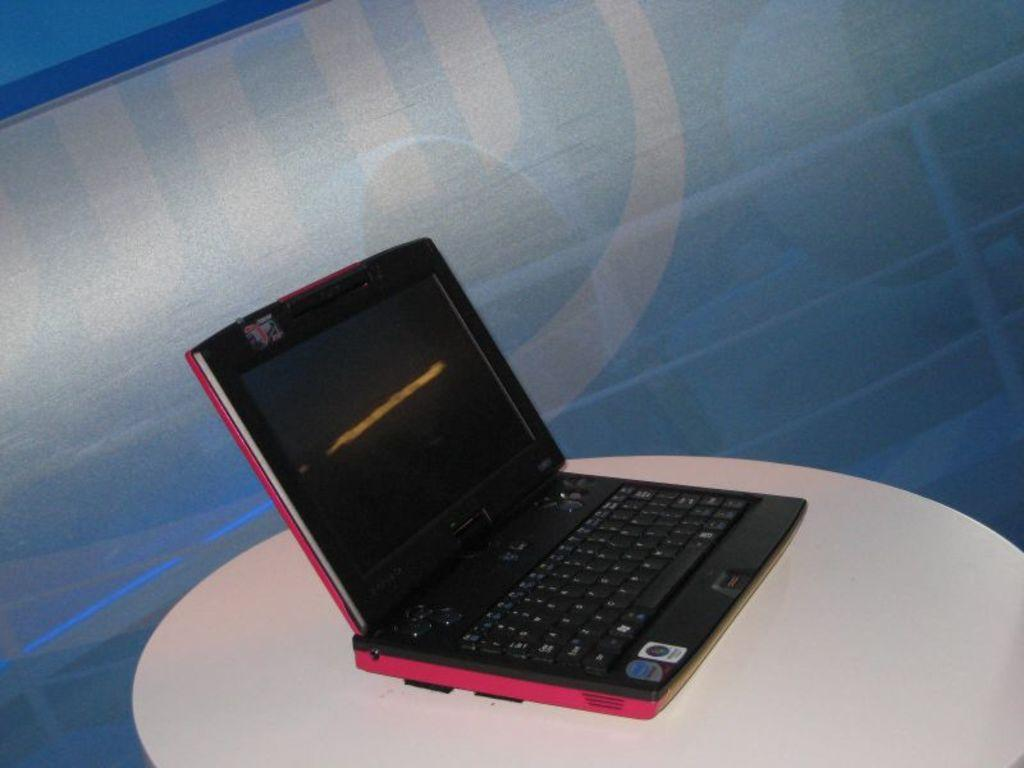What electronic device is visible in the image? There is a laptop in the image. Where is the laptop located? The laptop is placed on a table. What type of grape is being used to create a feast in the image? There is no grape or feast present in the image; it only features a laptop placed on a table. 